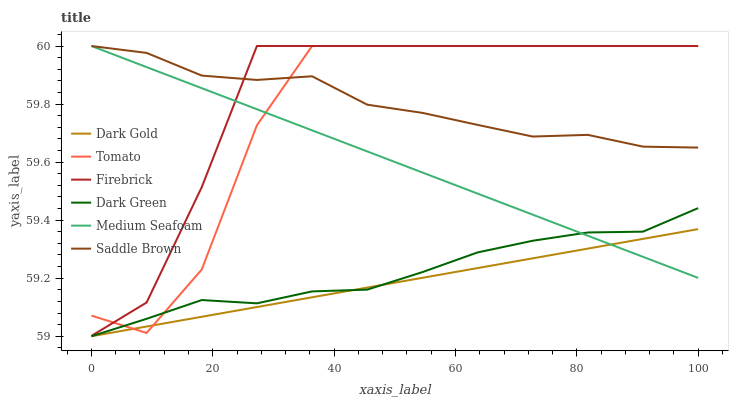Does Dark Gold have the minimum area under the curve?
Answer yes or no. Yes. Does Firebrick have the maximum area under the curve?
Answer yes or no. Yes. Does Firebrick have the minimum area under the curve?
Answer yes or no. No. Does Dark Gold have the maximum area under the curve?
Answer yes or no. No. Is Dark Gold the smoothest?
Answer yes or no. Yes. Is Tomato the roughest?
Answer yes or no. Yes. Is Firebrick the smoothest?
Answer yes or no. No. Is Firebrick the roughest?
Answer yes or no. No. Does Dark Gold have the lowest value?
Answer yes or no. Yes. Does Firebrick have the lowest value?
Answer yes or no. No. Does Saddle Brown have the highest value?
Answer yes or no. Yes. Does Dark Gold have the highest value?
Answer yes or no. No. Is Dark Green less than Firebrick?
Answer yes or no. Yes. Is Saddle Brown greater than Dark Green?
Answer yes or no. Yes. Does Medium Seafoam intersect Saddle Brown?
Answer yes or no. Yes. Is Medium Seafoam less than Saddle Brown?
Answer yes or no. No. Is Medium Seafoam greater than Saddle Brown?
Answer yes or no. No. Does Dark Green intersect Firebrick?
Answer yes or no. No. 